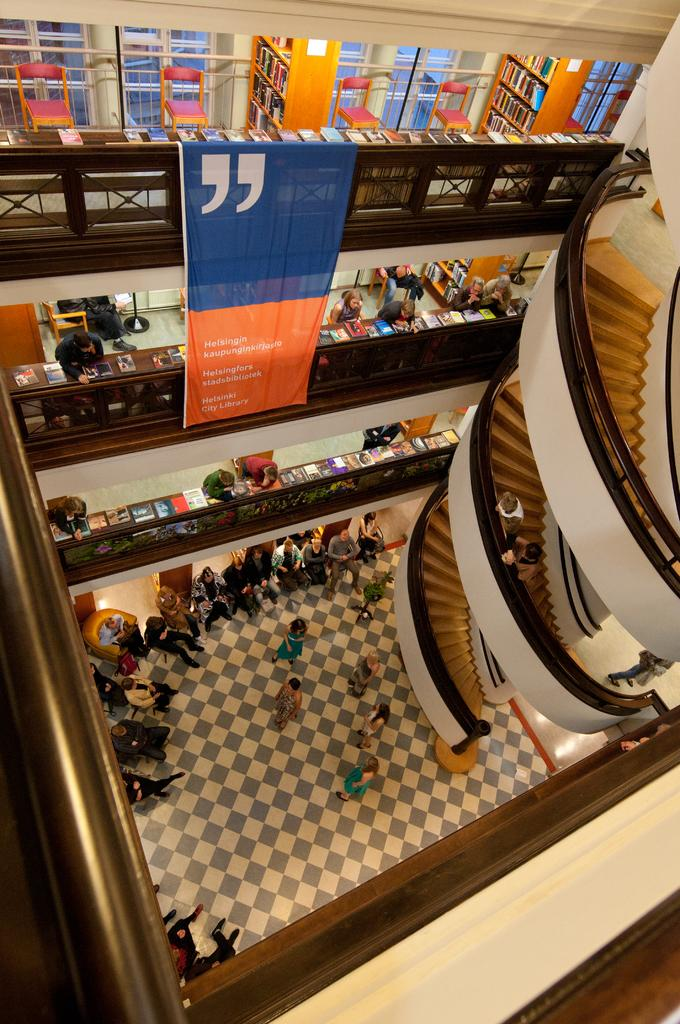What can be seen on the right side of the image? There are stairs on the right side of the image. What is located in the middle of the image? There are people in the middle of the image. What is visible in the background of the image? There is a banner in the background of the image. What type of furniture is at the top of the image? There are chairs at the top of the image. Can you tell me how many pigs are depicted on the banner in the image? There are no pigs depicted on the banner in the image. What type of machine is being used by the people in the middle of the image? There is no machine visible in the image; the people are not using any machinery. 